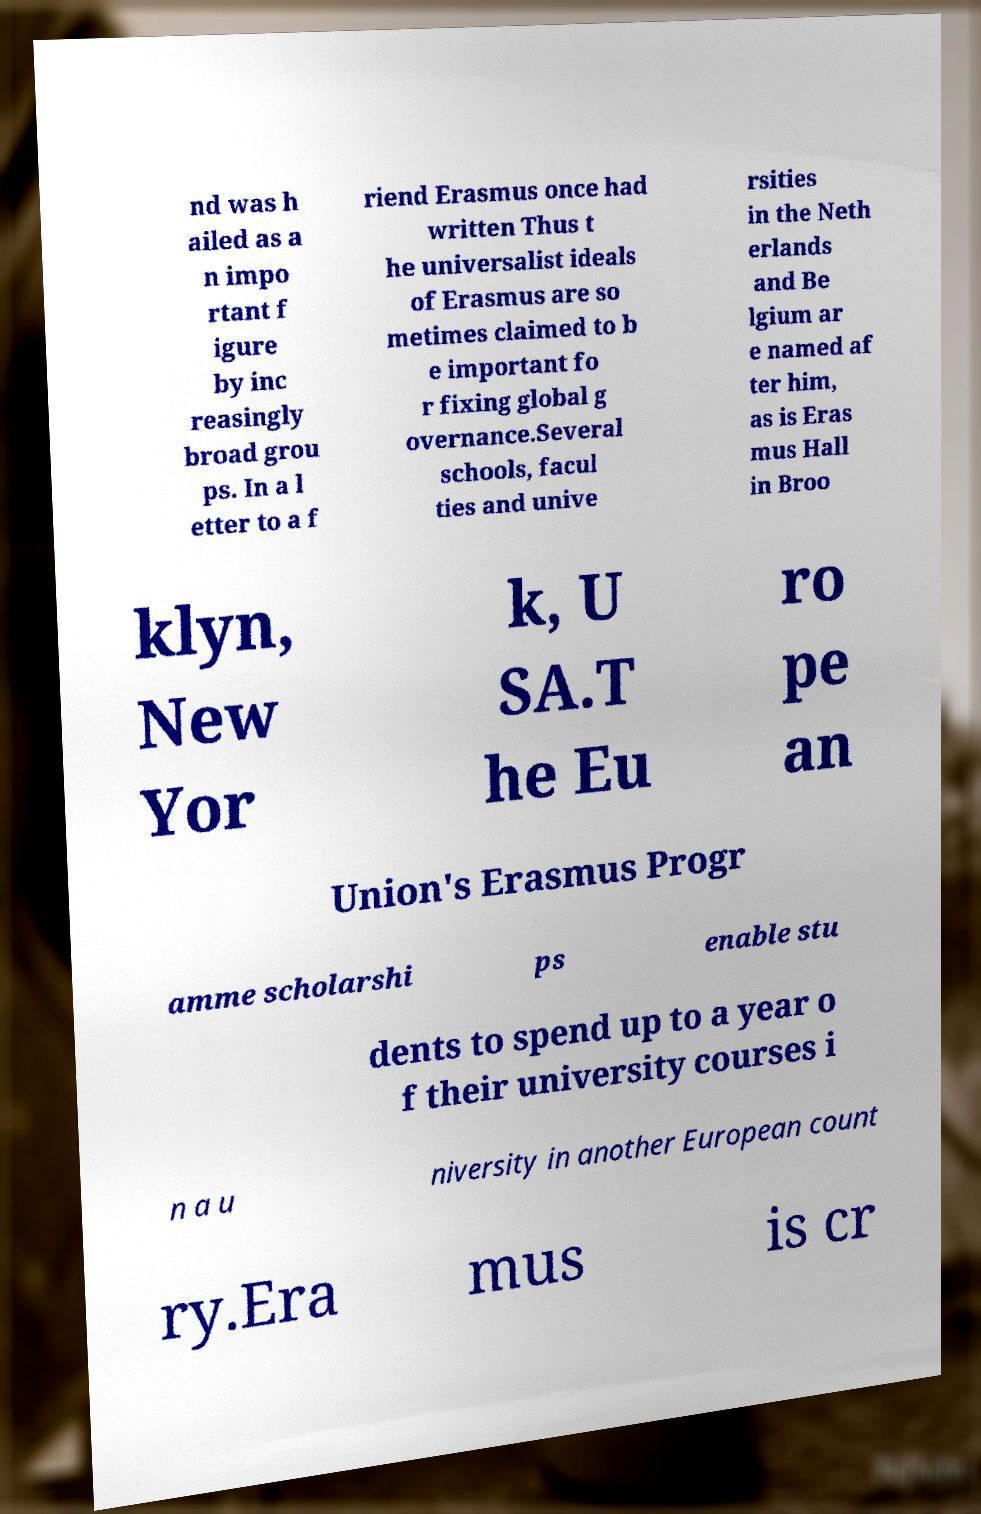Please identify and transcribe the text found in this image. nd was h ailed as a n impo rtant f igure by inc reasingly broad grou ps. In a l etter to a f riend Erasmus once had written Thus t he universalist ideals of Erasmus are so metimes claimed to b e important fo r fixing global g overnance.Several schools, facul ties and unive rsities in the Neth erlands and Be lgium ar e named af ter him, as is Eras mus Hall in Broo klyn, New Yor k, U SA.T he Eu ro pe an Union's Erasmus Progr amme scholarshi ps enable stu dents to spend up to a year o f their university courses i n a u niversity in another European count ry.Era mus is cr 